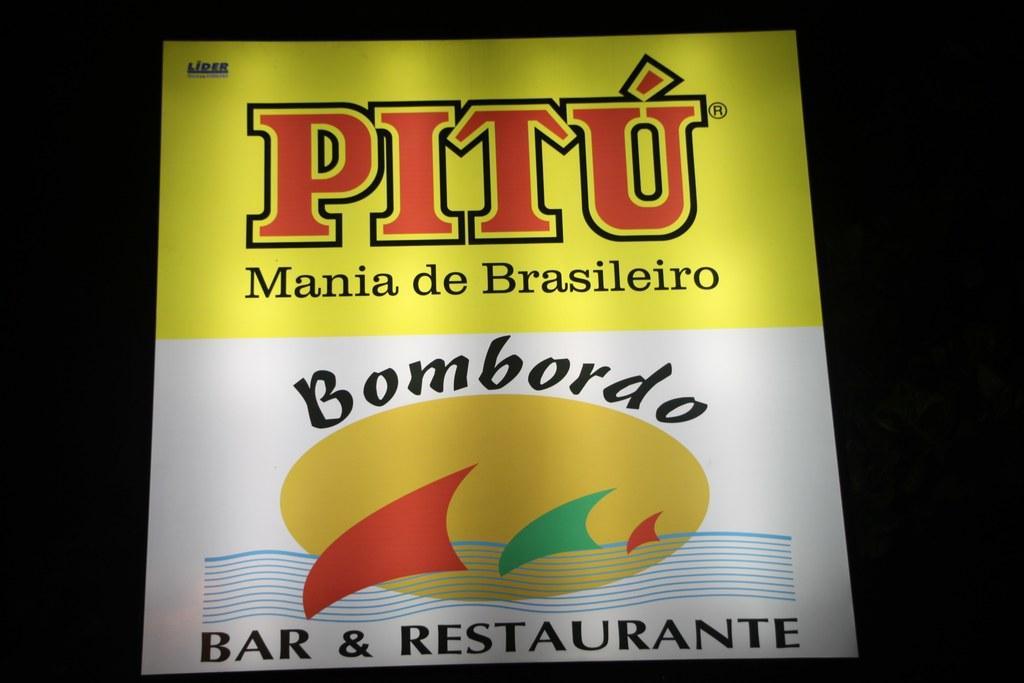Describe this image in one or two sentences. There is a poster with something written on that. In the background it is dark. 